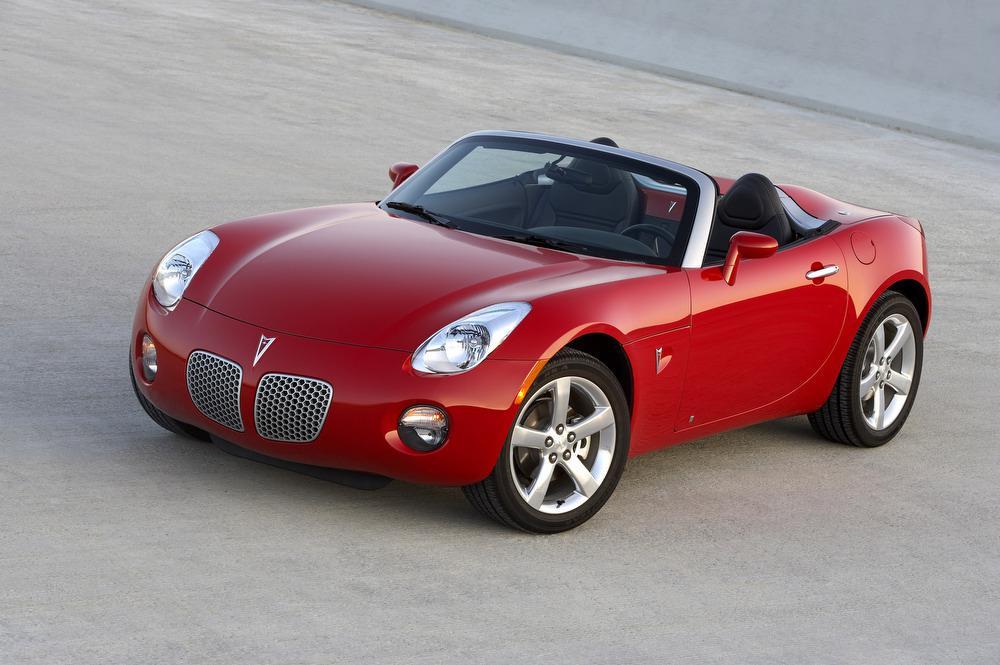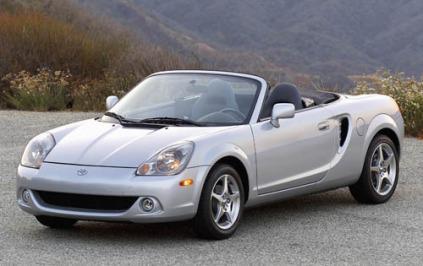The first image is the image on the left, the second image is the image on the right. For the images displayed, is the sentence "An image shows one red convertible with top down, turned at a leftward-facing angle." factually correct? Answer yes or no. Yes. The first image is the image on the left, the second image is the image on the right. Evaluate the accuracy of this statement regarding the images: "A red sportscar and a light colored sportscar are both convertibles with chrome wheels, black interiors, and logo at center front.". Is it true? Answer yes or no. Yes. 